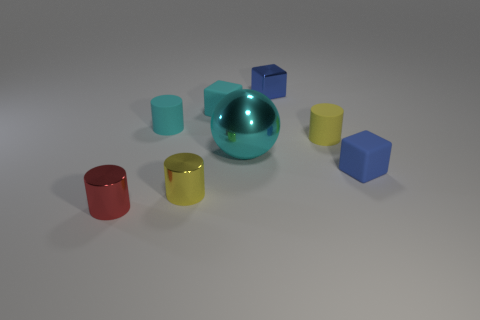If these objects had weights, which one do you think would be the heaviest? Assuming the objects are made from materials with similar density, the cyan sphere would likely be the heaviest due to its larger volume compared to the cylinders and cubes. 